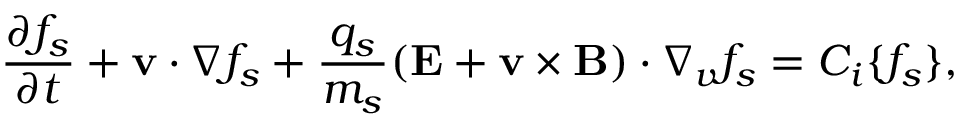<formula> <loc_0><loc_0><loc_500><loc_500>\frac { \partial f _ { s } } { \partial t } + { v } \cdot \nabla f _ { s } + \frac { q _ { s } } { m _ { s } } ( { E } + { v } \times { B } ) \cdot \nabla _ { v } f _ { s } = C _ { i } \{ f _ { s } \} ,</formula> 